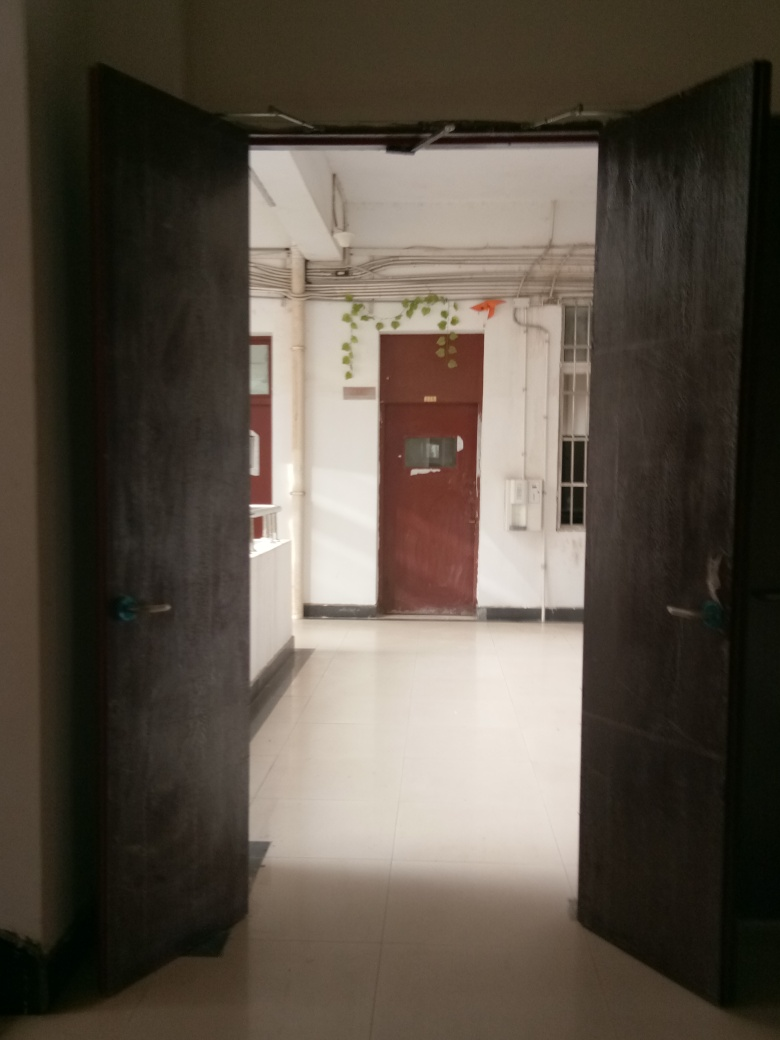What style or design is the door and does it indicate anything about the building? The door features a simple, functional design with minimal ornamentation, suggesting the building could be a commercial or institutional structure rather than a private residence, focusing on utility over aesthetic details. 